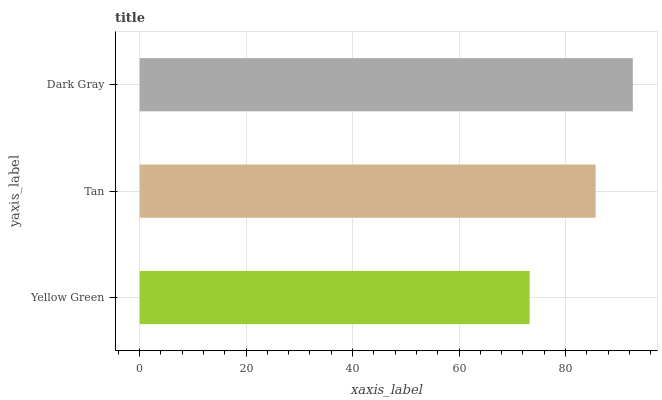Is Yellow Green the minimum?
Answer yes or no. Yes. Is Dark Gray the maximum?
Answer yes or no. Yes. Is Tan the minimum?
Answer yes or no. No. Is Tan the maximum?
Answer yes or no. No. Is Tan greater than Yellow Green?
Answer yes or no. Yes. Is Yellow Green less than Tan?
Answer yes or no. Yes. Is Yellow Green greater than Tan?
Answer yes or no. No. Is Tan less than Yellow Green?
Answer yes or no. No. Is Tan the high median?
Answer yes or no. Yes. Is Tan the low median?
Answer yes or no. Yes. Is Dark Gray the high median?
Answer yes or no. No. Is Yellow Green the low median?
Answer yes or no. No. 